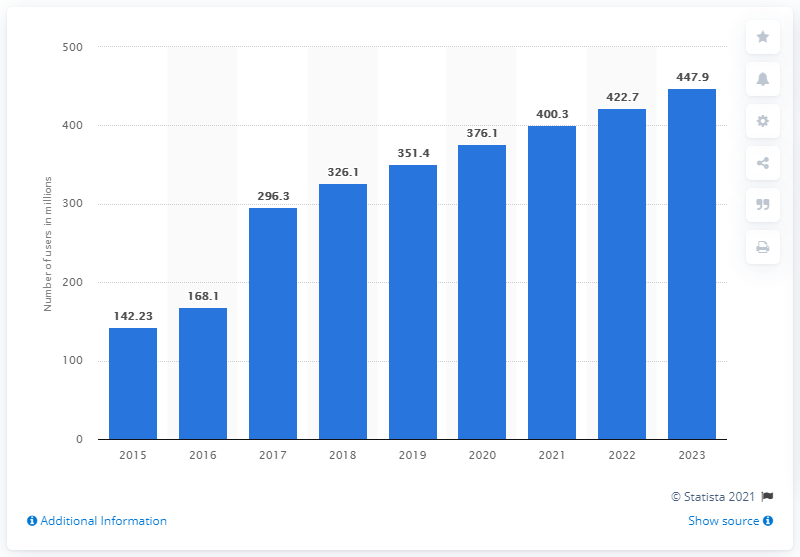Point out several critical features in this image. According to projections, the number of social network users in India is expected to reach 447.9 million in 2023. In 2018, the number of social media users in India was 326.1 million. It was predicted that in 2023, there would be 447.9 million social network users in India. The average forecast for the number of social network users in India over the next two years is expected to be approximately 435.3 million. 